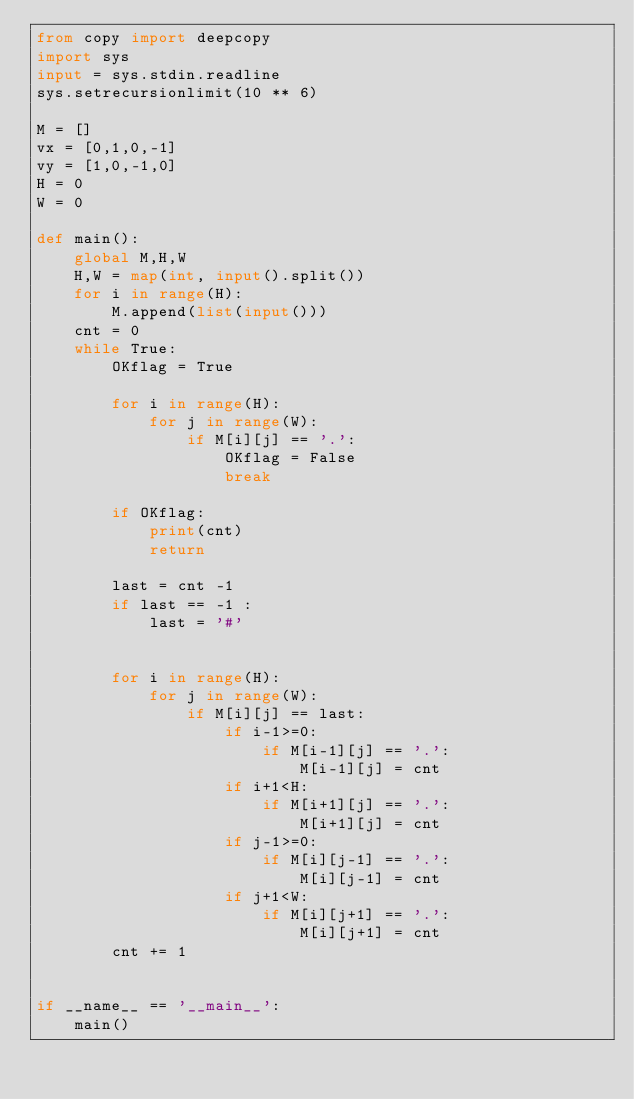<code> <loc_0><loc_0><loc_500><loc_500><_Python_>from copy import deepcopy
import sys
input = sys.stdin.readline
sys.setrecursionlimit(10 ** 6)

M = []
vx = [0,1,0,-1]
vy = [1,0,-1,0]
H = 0
W = 0

def main():
    global M,H,W
    H,W = map(int, input().split())  
    for i in range(H):
        M.append(list(input()))
    cnt = 0
    while True:
        OKflag = True
        
        for i in range(H):
            for j in range(W):
                if M[i][j] == '.':
                    OKflag = False
                    break

        if OKflag:
            print(cnt)
            return 

        last = cnt -1
        if last == -1 :
            last = '#'
        

        for i in range(H):
            for j in range(W):
                if M[i][j] == last:
                    if i-1>=0:
                        if M[i-1][j] == '.':
                            M[i-1][j] = cnt
                    if i+1<H:
                        if M[i+1][j] == '.':
                            M[i+1][j] = cnt
                    if j-1>=0:
                        if M[i][j-1] == '.':
                            M[i][j-1] = cnt
                    if j+1<W:
                        if M[i][j+1] == '.':
                            M[i][j+1] = cnt
        cnt += 1


if __name__ == '__main__':
    main()

</code> 